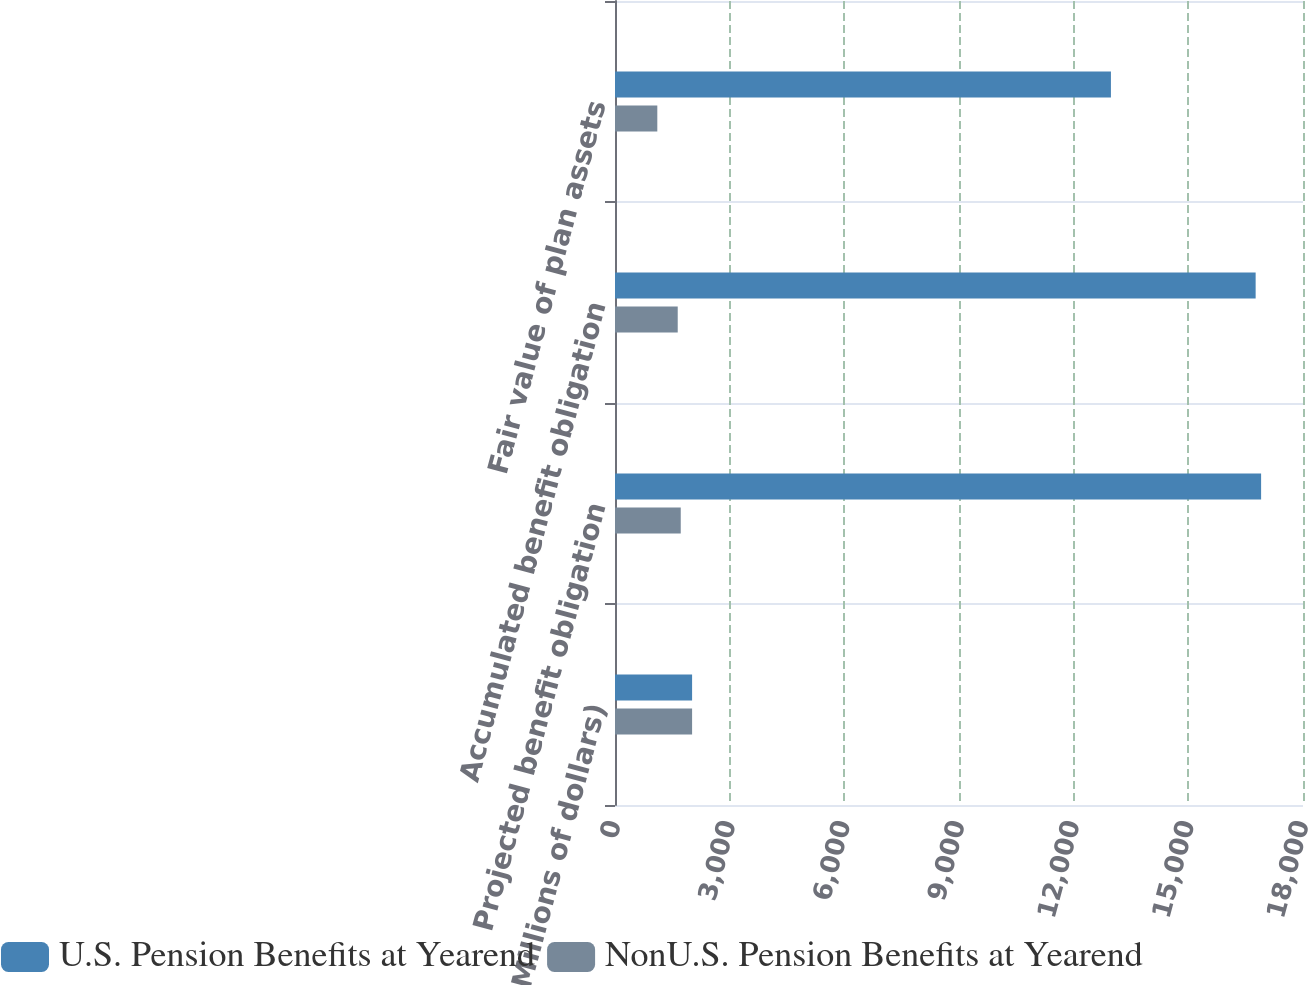Convert chart to OTSL. <chart><loc_0><loc_0><loc_500><loc_500><stacked_bar_chart><ecel><fcel>(Millions of dollars)<fcel>Projected benefit obligation<fcel>Accumulated benefit obligation<fcel>Fair value of plan assets<nl><fcel>U.S. Pension Benefits at Yearend<fcel>2017<fcel>16904<fcel>16761<fcel>12975<nl><fcel>NonU.S. Pension Benefits at Yearend<fcel>2017<fcel>1720<fcel>1641<fcel>1107<nl></chart> 